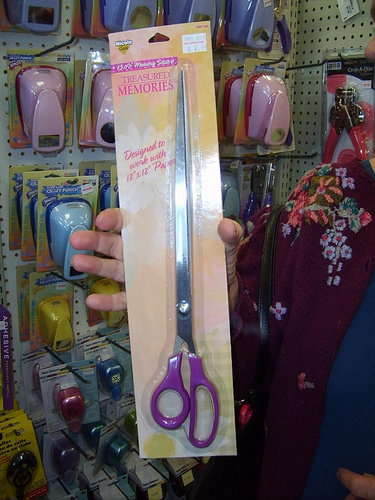Identify the text contained in this image. MEMORIES dougined to work ADHESIVE PN 